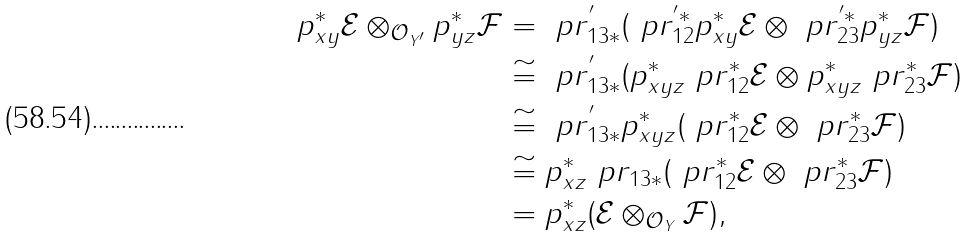Convert formula to latex. <formula><loc_0><loc_0><loc_500><loc_500>p _ { x y } ^ { * } \mathcal { E } \otimes _ { { \mathcal { O } } _ { Y ^ { \prime } } } p _ { y z } ^ { * } \mathcal { F } & = \ p r _ { 1 3 * } ^ { ^ { \prime } } ( \ p r _ { 1 2 } ^ { ^ { \prime } * } p _ { x y } ^ { * } \mathcal { E } \otimes \ p r _ { 2 3 } ^ { ^ { \prime } * } p _ { y z } ^ { * } \mathcal { F } ) \\ & \cong \ p r _ { 1 3 * } ^ { ^ { \prime } } ( p _ { x y z } ^ { * } \ p r _ { 1 2 } ^ { * } \mathcal { E } \otimes p _ { x y z } ^ { * } \ p r _ { 2 3 } ^ { * } \mathcal { F } ) \\ & \cong \ p r _ { 1 3 * } ^ { ^ { \prime } } p _ { x y z } ^ { * } ( \ p r _ { 1 2 } ^ { * } \mathcal { E } \otimes \ p r _ { 2 3 } ^ { * } \mathcal { F } ) \\ & \cong p _ { x z } ^ { * } \ p r _ { 1 3 * } ( \ p r _ { 1 2 } ^ { * } \mathcal { E } \otimes \ p r _ { 2 3 } ^ { * } \mathcal { F } ) \\ & = p _ { x z } ^ { * } ( \mathcal { E } \otimes _ { { \mathcal { O } } _ { Y } } \mathcal { F } ) ,</formula> 